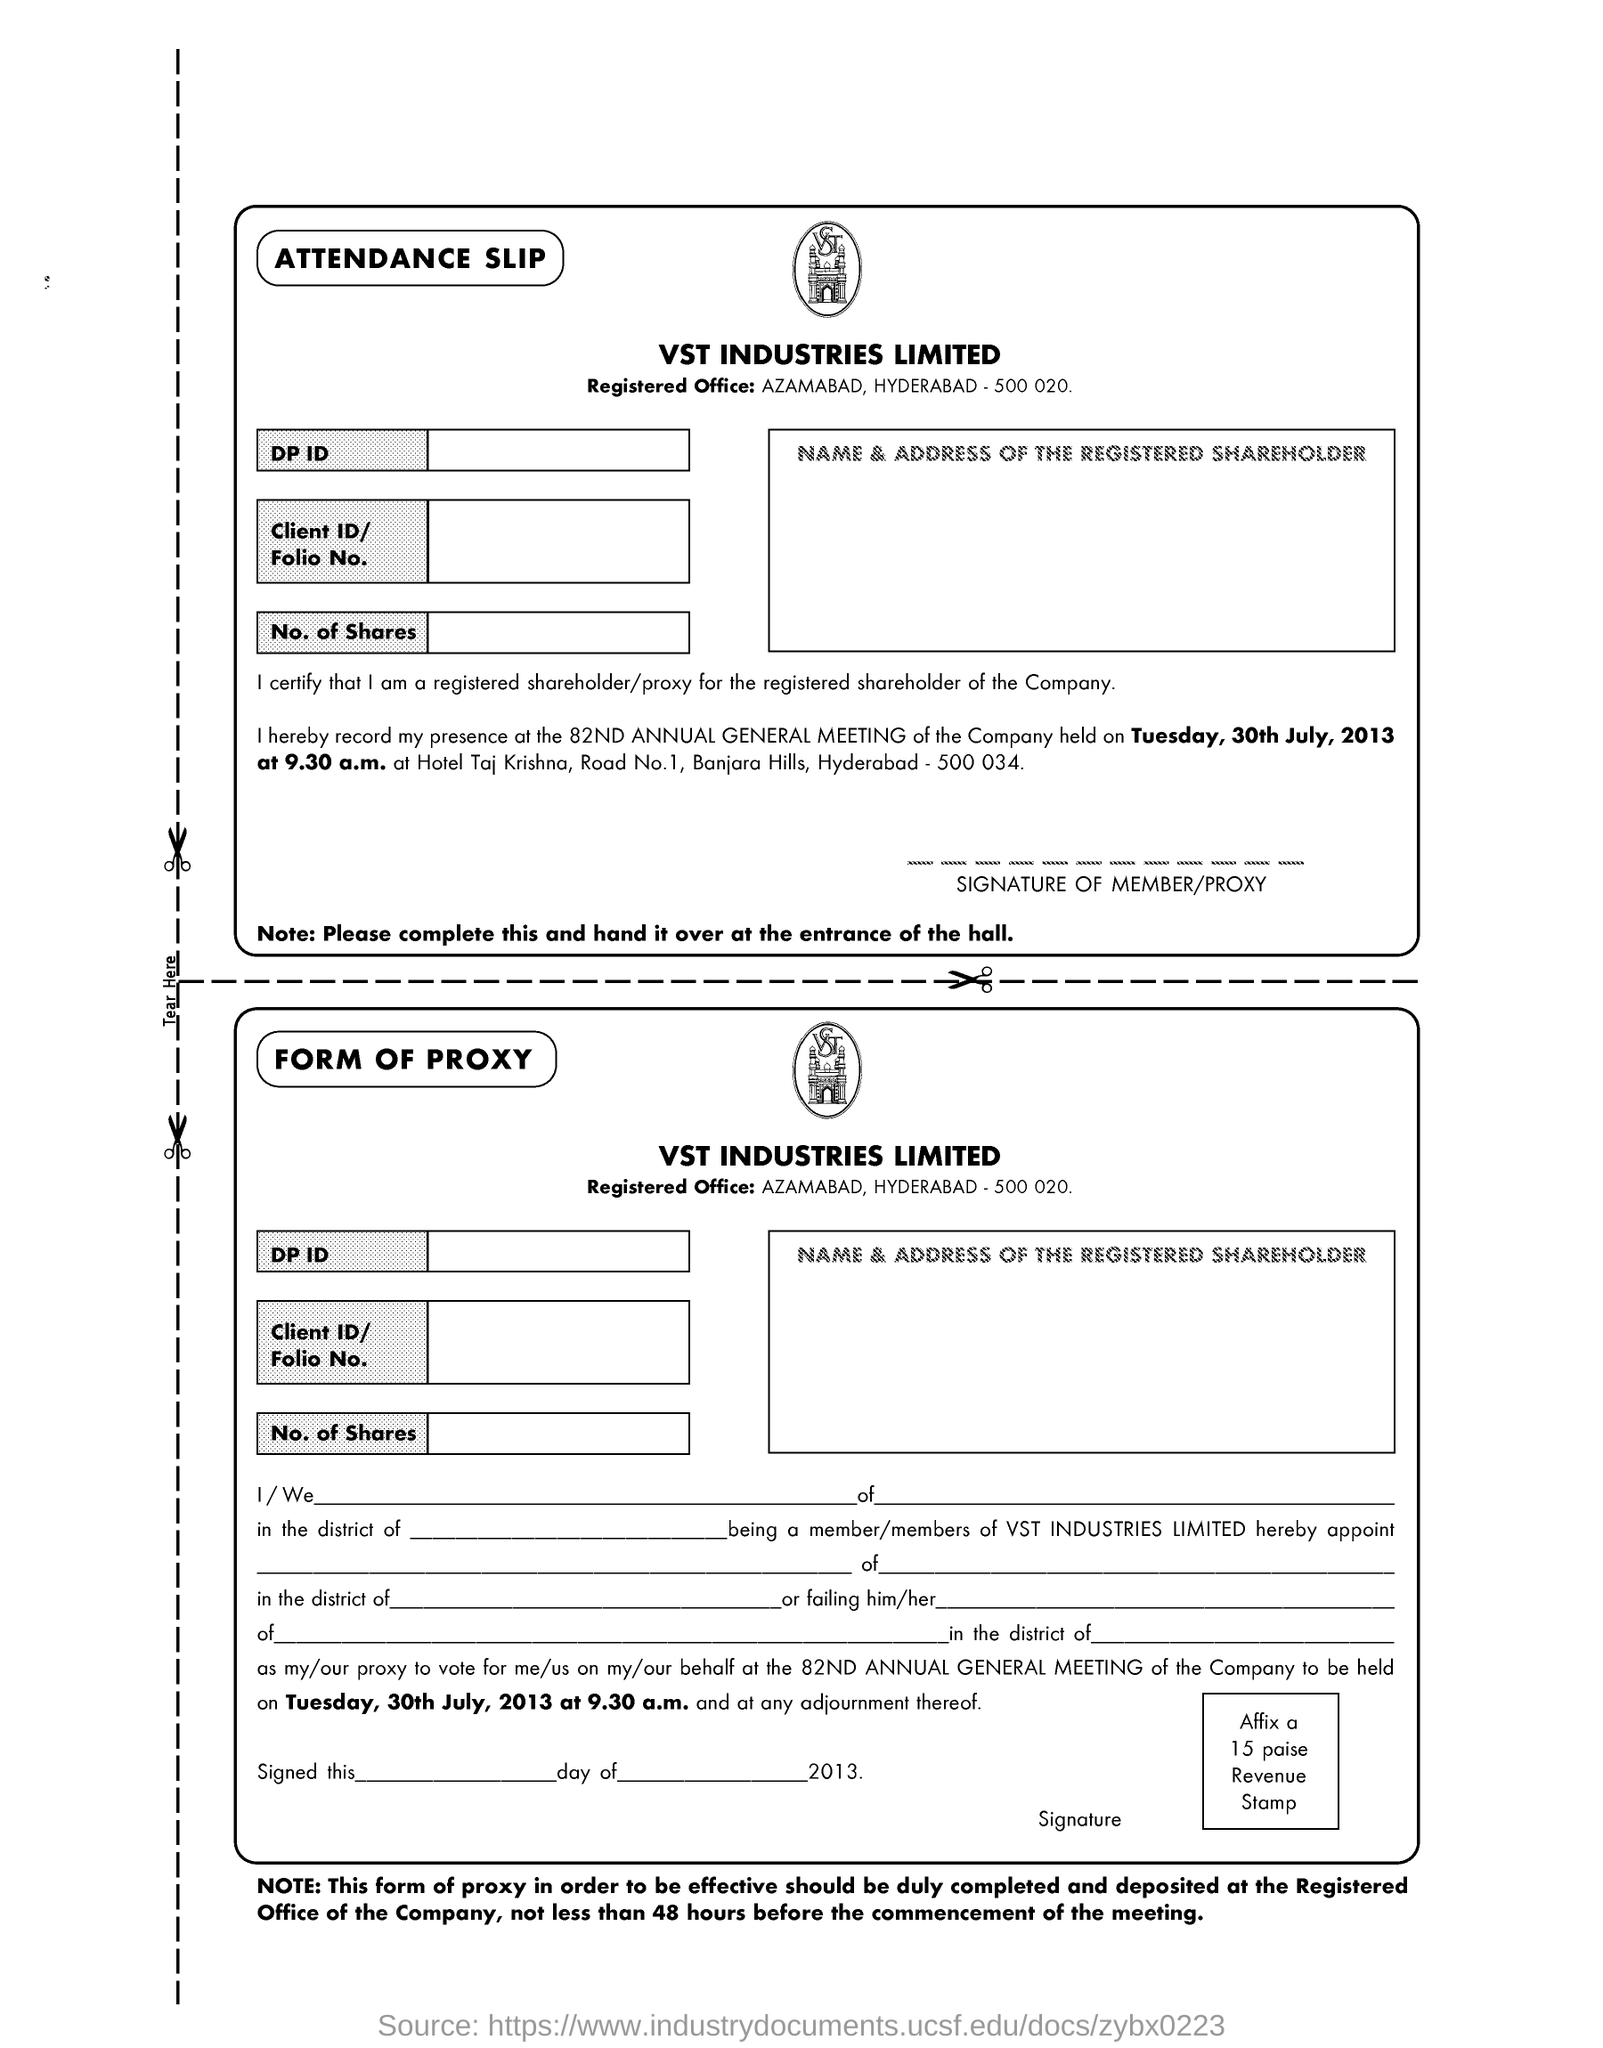Which industry is mentioned in the document ?
Your response must be concise. VST. What is the location of the Registered Office ?
Offer a terse response. AZAMABAD, HYDERABAD -500 020. What meeting is held on tuesday, 30th july, 2013 ?
Your answer should be compact. 82ND ANNUAL GENERAL MEETING. Where to hand over the attendance slip ?
Provide a short and direct response. Entrance of the hall. 